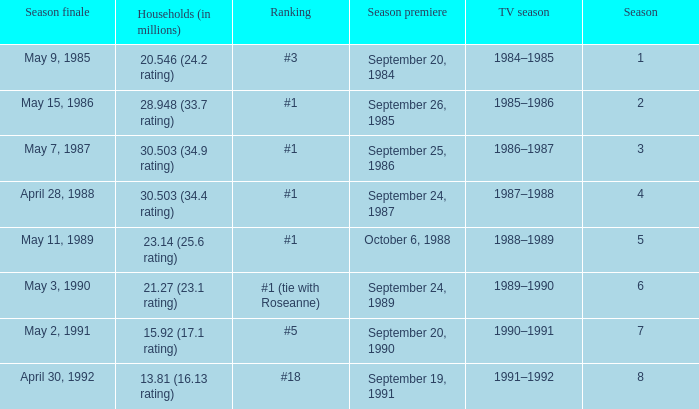Which TV season has a Season larger than 2, and a Ranking of #5? 1990–1991. 